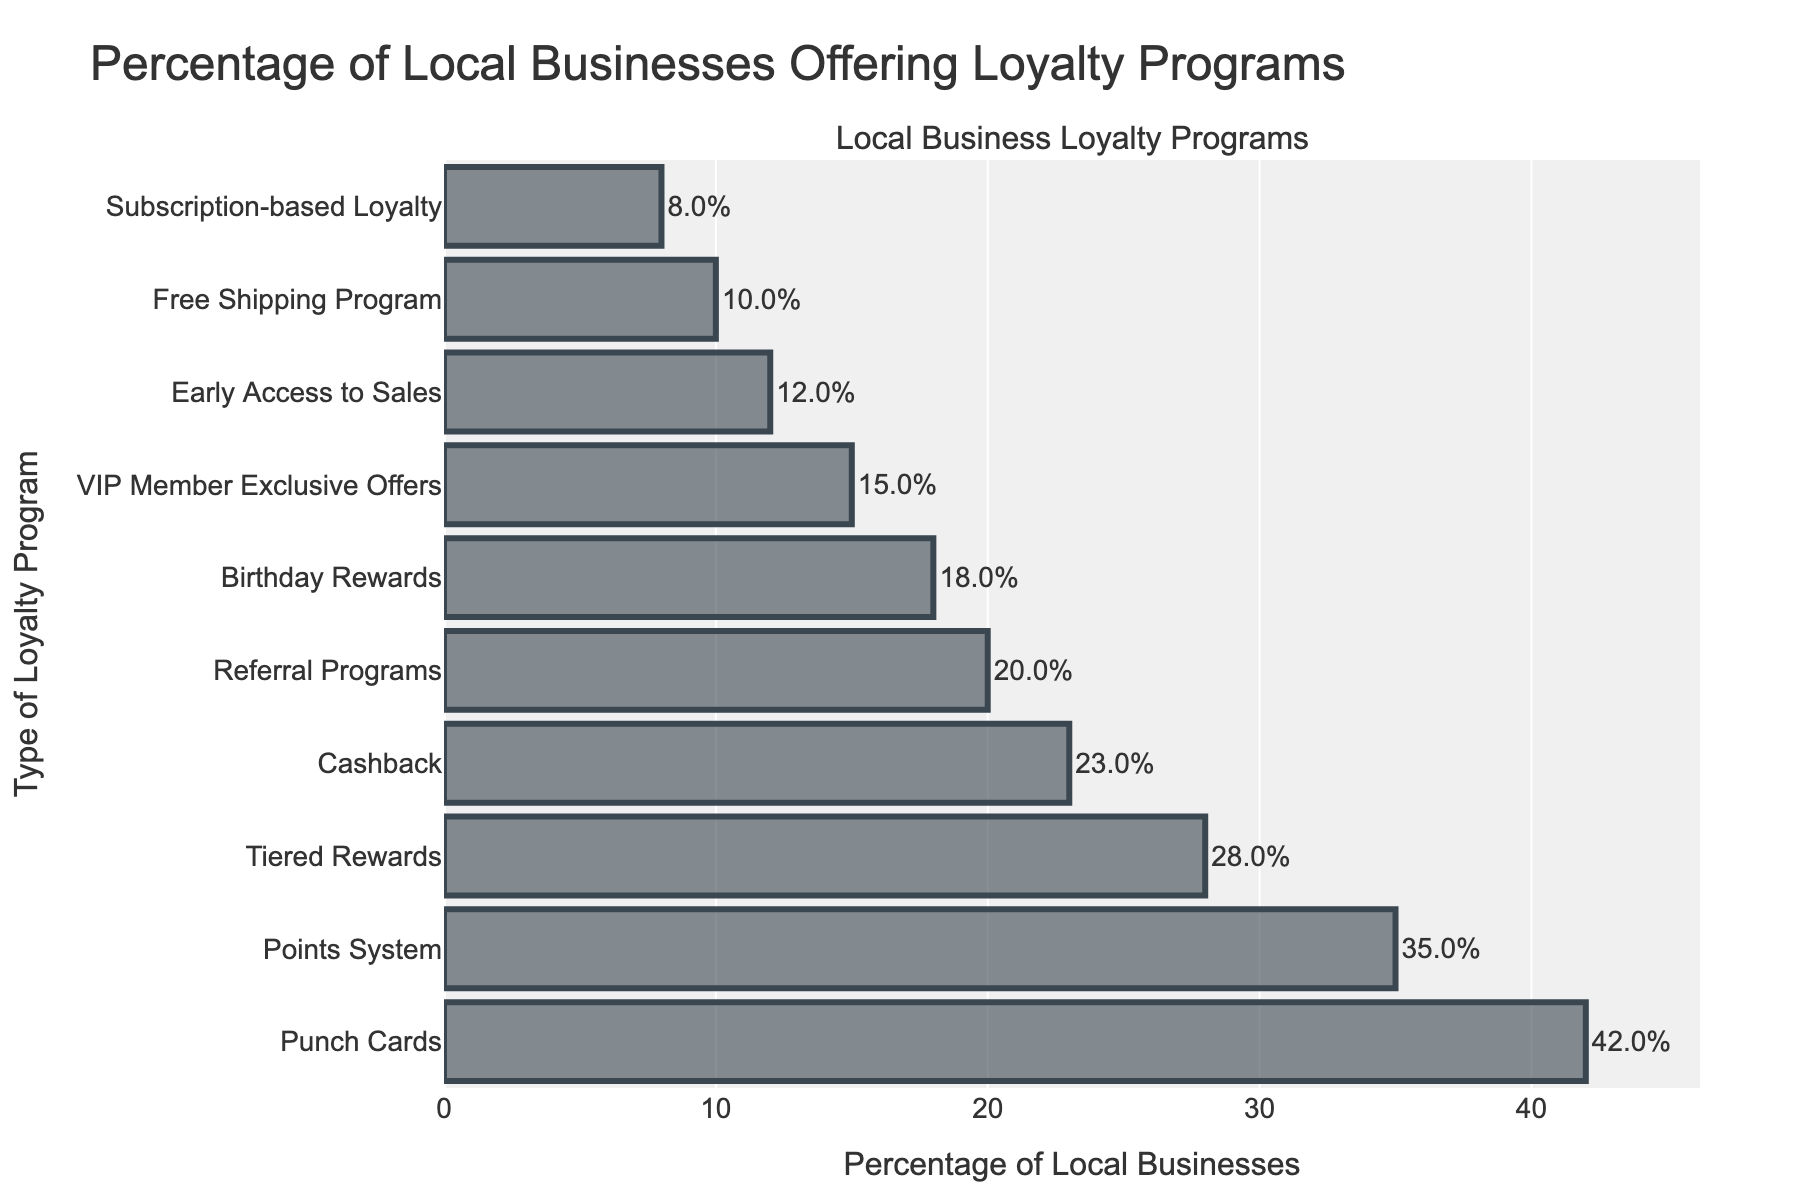What percentage of local businesses offer Punch Cards loyalty programs? The figure shows that the bar labeled "Punch Cards" extends to a value on the x-axis corresponding to 42. This indicates that 42% of local businesses offer Punch Cards loyalty programs.
Answer: 42% Which loyalty program is offered by the fewest local businesses? The bar corresponding to "Subscription-based Loyalty" is the shortest, extending to the smallest value on the x-axis, which is 8%. This indicates that this program is offered by the fewest local businesses.
Answer: Subscription-based Loyalty How many percentage points more do businesses offer Punch Cards compared to Cashback programs? The figure shows the value for Punch Cards as 42% and Cashback as 23%. The difference is 42 - 23 = 19 percentage points.
Answer: 19 What is the combined percentage of businesses offering Points System and Birthday Rewards programs? The Points System program is offered by 35% of businesses, and Birthday Rewards is offered by 18%. The combined percentage is 35 + 18 = 53%.
Answer: 53% Which loyalty programs are offered by more than 20% of local businesses? The figure shows bars extending beyond the 20% mark for Punch Cards (42%), Points System (35%), Tiered Rewards (28%), and Cashback (23%). These programs are all offered by more than 20% of local businesses.
Answer: Punch Cards, Points System, Tiered Rewards, Cashback Which program has a higher percentage of businesses offering it: VIP Member Exclusive Offers or Referral Programs? The bar for Referral Programs extends to 20%, while the one for VIP Member Exclusive Offers extends to 15%. Referral Programs have a higher percentage.
Answer: Referral Programs What is the total percentage of businesses offering either Early Access to Sales or Free Shipping Program? The Early Access to Sales program is offered by 12% of businesses, and the Free Shipping Program is offered by 10%. The total percentage is 12 + 10 = 22%.
Answer: 22% What is the percentage difference between businesses offering Tiered Rewards and Birthday Rewards? The figure indicates that 28% of businesses offer Tiered Rewards, while 18% offer Birthday Rewards. The percentage difference is 28 - 18 = 10%.
Answer: 10% Compare the total percentage of businesses offering either Points System or Cashback programs to those offering VIP Member Exclusive Offers. Which one is higher and by how much? The Points System is offered by 35%, and the Cashback by 23%, totaling 35 + 23 = 58%. VIP Member Exclusive Offers are offered by 15%. The difference is 58 - 15 = 43%. The total percentage for Points System or Cashback is higher by 43%.
Answer: Points System or Cashback by 43% Which loyalty programs have a percentage offering within 5 percentage points of 20%? The bars closest to the 20% mark are for Referral Programs at 20%, Cashback at 23%, and Birthday Rewards at 18%. Both Cashback, at 23%, and Birthday Rewards, at 18%, fall within 5 percentage points of 20%.
Answer: Cashback, Birthday Rewards, Referral Programs 